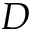<formula> <loc_0><loc_0><loc_500><loc_500>D</formula> 